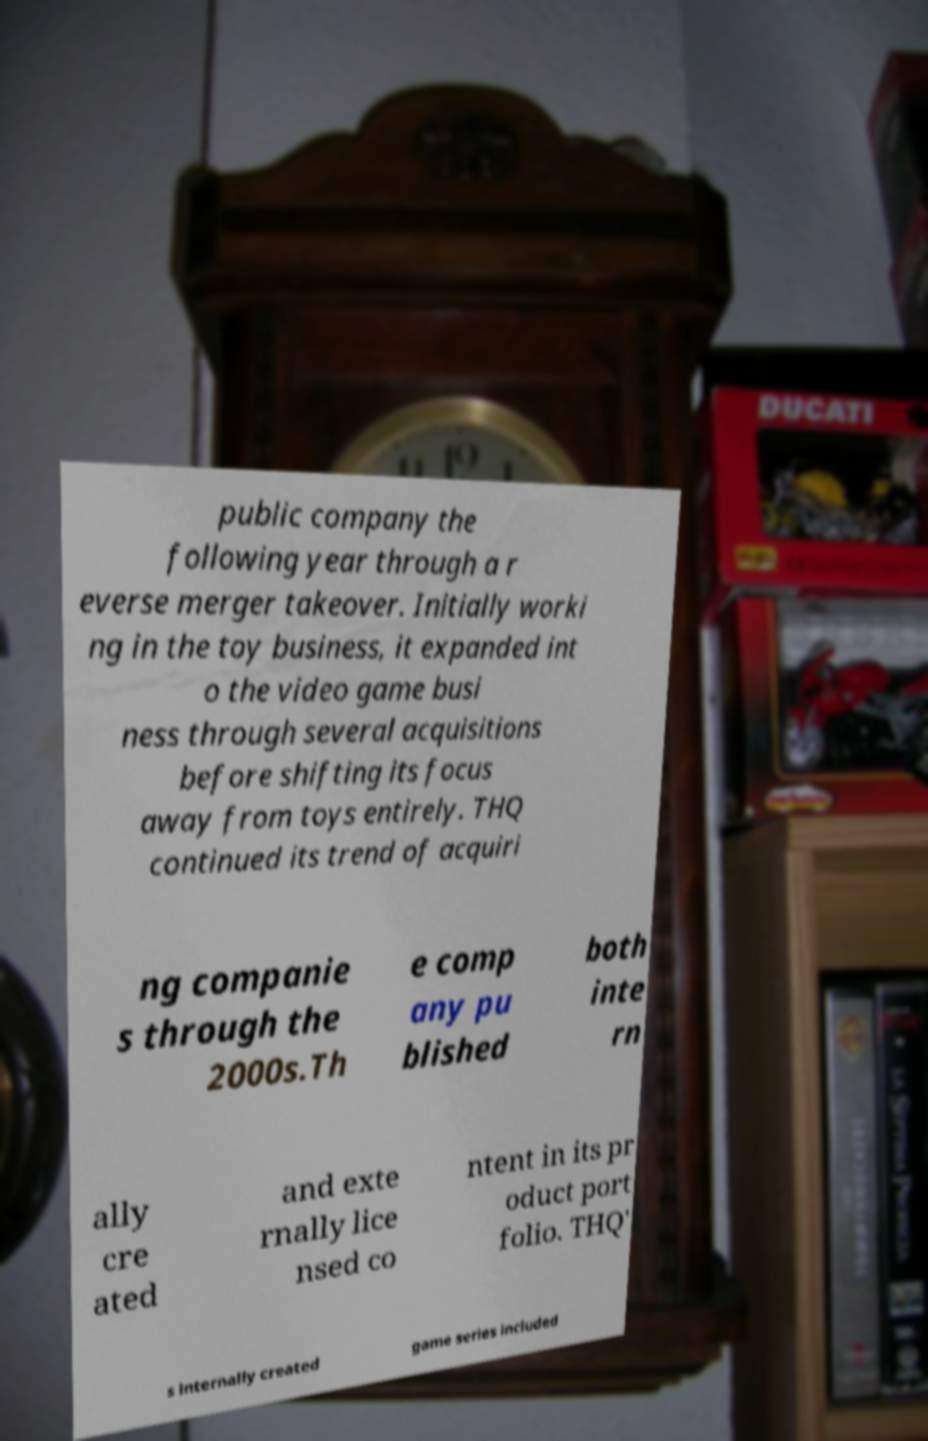For documentation purposes, I need the text within this image transcribed. Could you provide that? public company the following year through a r everse merger takeover. Initially worki ng in the toy business, it expanded int o the video game busi ness through several acquisitions before shifting its focus away from toys entirely. THQ continued its trend of acquiri ng companie s through the 2000s.Th e comp any pu blished both inte rn ally cre ated and exte rnally lice nsed co ntent in its pr oduct port folio. THQ' s internally created game series included 